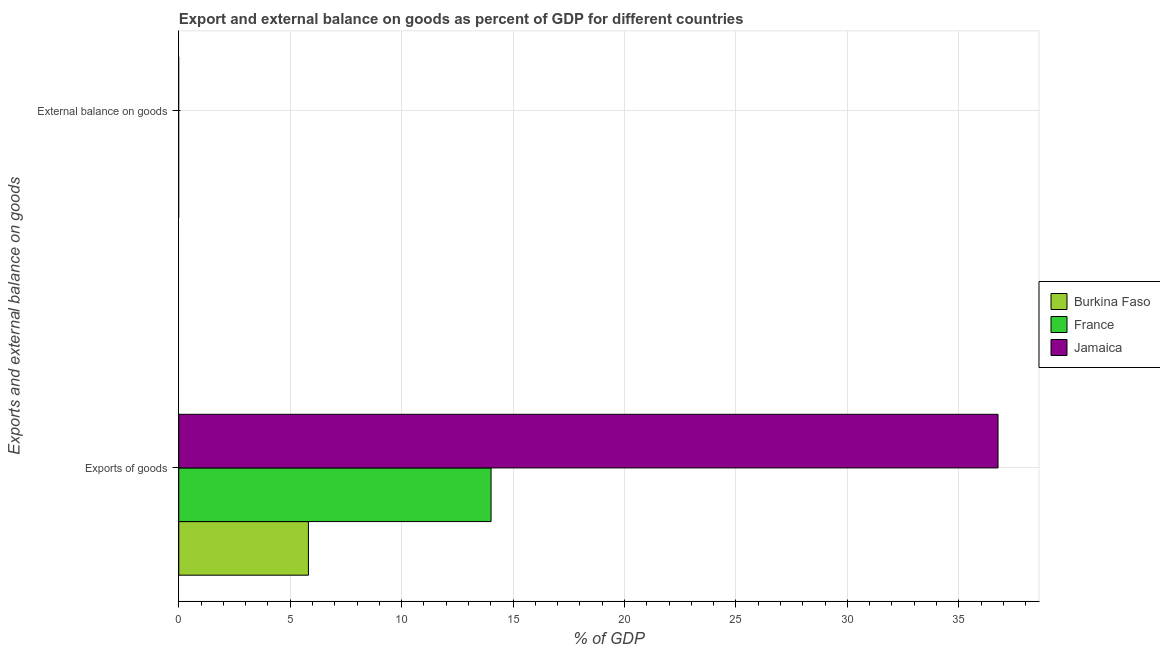Are the number of bars on each tick of the Y-axis equal?
Offer a terse response. No. How many bars are there on the 1st tick from the bottom?
Make the answer very short. 3. What is the label of the 2nd group of bars from the top?
Provide a succinct answer. Exports of goods. Across all countries, what is the maximum export of goods as percentage of gdp?
Offer a very short reply. 36.76. Across all countries, what is the minimum export of goods as percentage of gdp?
Offer a very short reply. 5.82. In which country was the export of goods as percentage of gdp maximum?
Make the answer very short. Jamaica. What is the difference between the export of goods as percentage of gdp in Jamaica and that in Burkina Faso?
Ensure brevity in your answer.  30.94. What is the difference between the export of goods as percentage of gdp in France and the external balance on goods as percentage of gdp in Jamaica?
Your answer should be very brief. 14.01. What is the average external balance on goods as percentage of gdp per country?
Your answer should be very brief. 0. What is the ratio of the export of goods as percentage of gdp in Burkina Faso to that in Jamaica?
Offer a terse response. 0.16. Is the export of goods as percentage of gdp in Burkina Faso less than that in France?
Offer a terse response. Yes. In how many countries, is the external balance on goods as percentage of gdp greater than the average external balance on goods as percentage of gdp taken over all countries?
Make the answer very short. 0. How many bars are there?
Provide a succinct answer. 3. Are all the bars in the graph horizontal?
Your answer should be compact. Yes. What is the difference between two consecutive major ticks on the X-axis?
Your answer should be very brief. 5. Are the values on the major ticks of X-axis written in scientific E-notation?
Give a very brief answer. No. Where does the legend appear in the graph?
Provide a short and direct response. Center right. How are the legend labels stacked?
Offer a very short reply. Vertical. What is the title of the graph?
Make the answer very short. Export and external balance on goods as percent of GDP for different countries. What is the label or title of the X-axis?
Your answer should be compact. % of GDP. What is the label or title of the Y-axis?
Offer a terse response. Exports and external balance on goods. What is the % of GDP in Burkina Faso in Exports of goods?
Offer a very short reply. 5.82. What is the % of GDP of France in Exports of goods?
Your answer should be very brief. 14.01. What is the % of GDP in Jamaica in Exports of goods?
Give a very brief answer. 36.76. What is the % of GDP in Burkina Faso in External balance on goods?
Ensure brevity in your answer.  0. What is the % of GDP of Jamaica in External balance on goods?
Keep it short and to the point. 0. Across all Exports and external balance on goods, what is the maximum % of GDP in Burkina Faso?
Offer a very short reply. 5.82. Across all Exports and external balance on goods, what is the maximum % of GDP in France?
Offer a very short reply. 14.01. Across all Exports and external balance on goods, what is the maximum % of GDP in Jamaica?
Offer a very short reply. 36.76. What is the total % of GDP of Burkina Faso in the graph?
Offer a very short reply. 5.82. What is the total % of GDP in France in the graph?
Offer a terse response. 14.01. What is the total % of GDP of Jamaica in the graph?
Make the answer very short. 36.76. What is the average % of GDP of Burkina Faso per Exports and external balance on goods?
Provide a short and direct response. 2.91. What is the average % of GDP in France per Exports and external balance on goods?
Provide a short and direct response. 7.01. What is the average % of GDP of Jamaica per Exports and external balance on goods?
Keep it short and to the point. 18.38. What is the difference between the % of GDP in Burkina Faso and % of GDP in France in Exports of goods?
Your answer should be compact. -8.19. What is the difference between the % of GDP in Burkina Faso and % of GDP in Jamaica in Exports of goods?
Your response must be concise. -30.94. What is the difference between the % of GDP of France and % of GDP of Jamaica in Exports of goods?
Your answer should be compact. -22.75. What is the difference between the highest and the lowest % of GDP in Burkina Faso?
Ensure brevity in your answer.  5.82. What is the difference between the highest and the lowest % of GDP in France?
Keep it short and to the point. 14.01. What is the difference between the highest and the lowest % of GDP of Jamaica?
Your response must be concise. 36.76. 